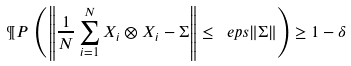<formula> <loc_0><loc_0><loc_500><loc_500>\P P \, \left ( \left \| \frac { 1 } { N } \sum _ { i = 1 } ^ { N } X _ { i } \otimes X _ { i } - \Sigma \right \| \leq \ e p s \| \Sigma \| \right ) \geq 1 - \delta</formula> 